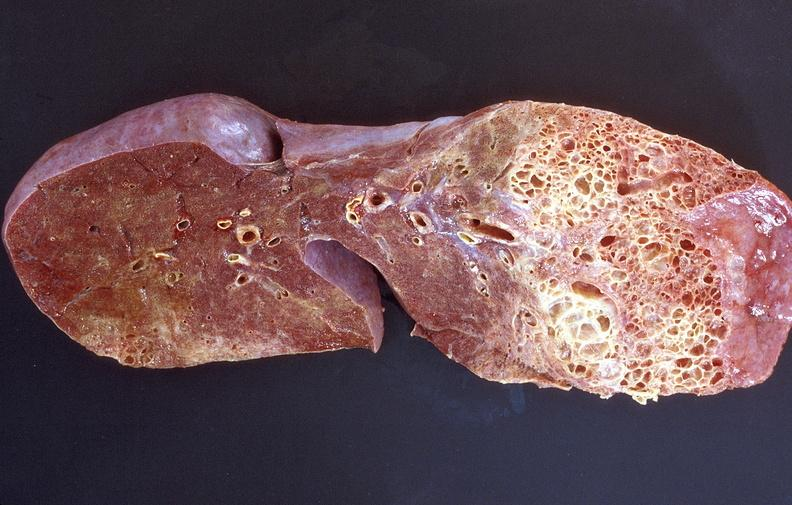s respiratory present?
Answer the question using a single word or phrase. Yes 